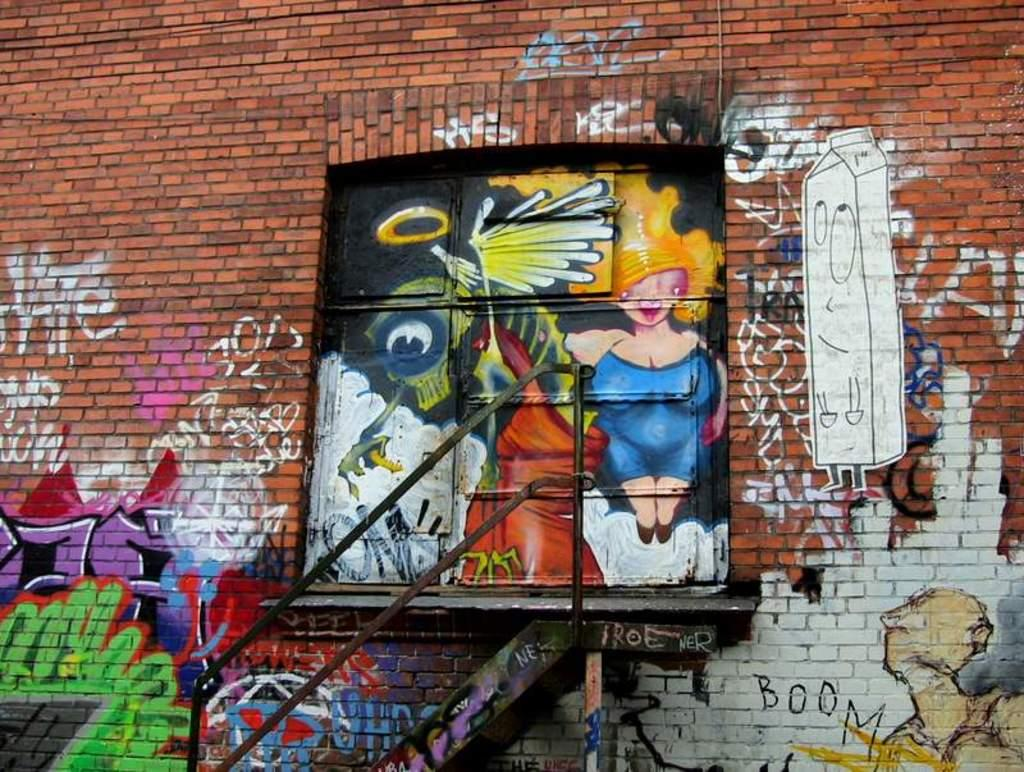What type of structure is visible in the image? There is a brick wall in the image. What is on the brick wall? There is a painting on the wall. What type of powder is sprinkled on the pie in the image? There is no pie present in the image, so it is not possible to determine if there is any powder on it. 